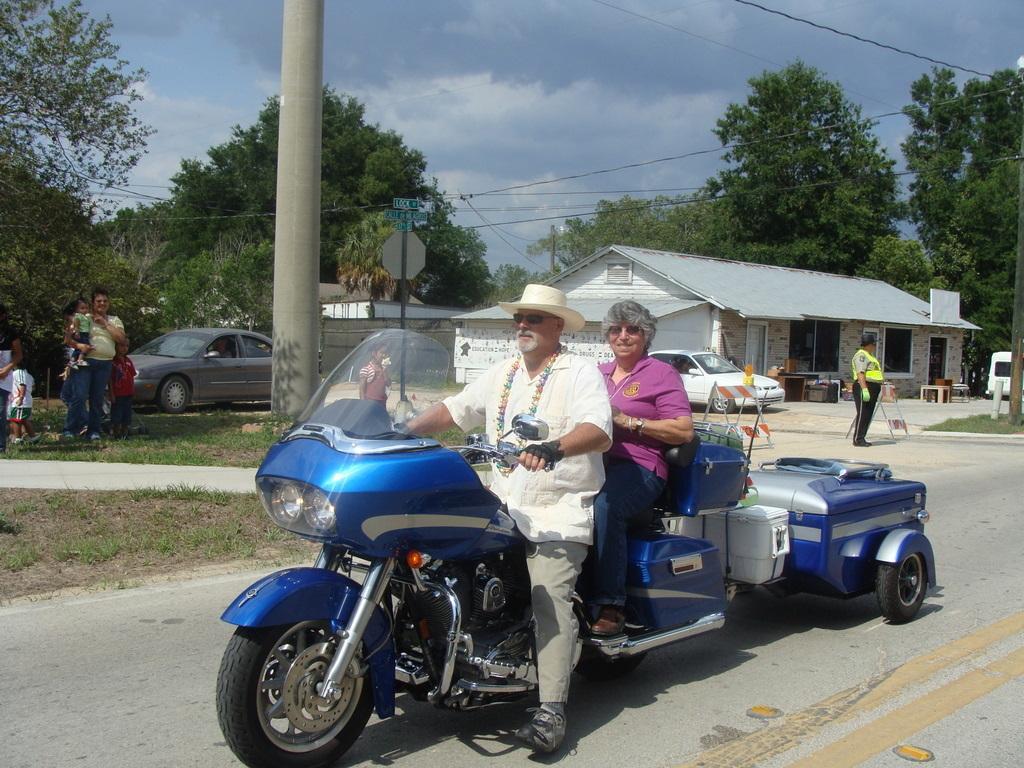Can you describe this image briefly? The person wearing a hat is sitting on a bike and there is a women behind him and there are trees,buildings and car in the background 